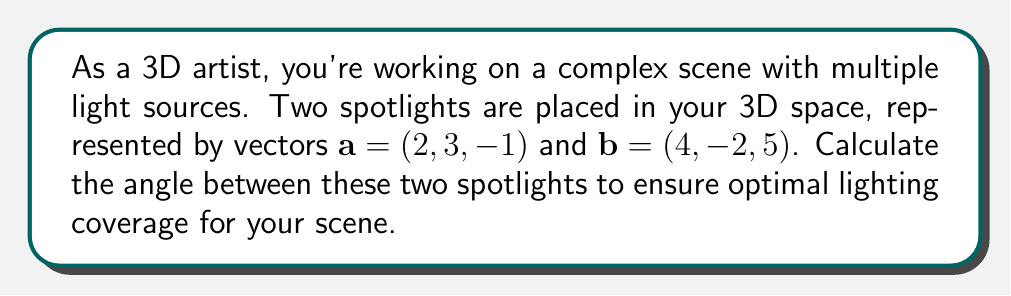Teach me how to tackle this problem. To calculate the angle between two vectors in 3D space, we can use the dot product formula:

$$\cos \theta = \frac{\mathbf{a} \cdot \mathbf{b}}{|\mathbf{a}||\mathbf{b}|}$$

Where $\theta$ is the angle between the vectors, $\mathbf{a} \cdot \mathbf{b}$ is the dot product of the vectors, and $|\mathbf{a}|$ and $|\mathbf{b}|$ are the magnitudes of vectors $\mathbf{a}$ and $\mathbf{b}$ respectively.

Step 1: Calculate the dot product $\mathbf{a} \cdot \mathbf{b}$
$$\mathbf{a} \cdot \mathbf{b} = (2)(4) + (3)(-2) + (-1)(5) = 8 - 6 - 5 = -3$$

Step 2: Calculate the magnitudes of vectors $\mathbf{a}$ and $\mathbf{b}$
$$|\mathbf{a}| = \sqrt{2^2 + 3^2 + (-1)^2} = \sqrt{4 + 9 + 1} = \sqrt{14}$$
$$|\mathbf{b}| = \sqrt{4^2 + (-2)^2 + 5^2} = \sqrt{16 + 4 + 25} = \sqrt{45}$$

Step 3: Apply the dot product formula
$$\cos \theta = \frac{-3}{\sqrt{14}\sqrt{45}}$$

Step 4: Calculate $\theta$ using the inverse cosine (arccos) function
$$\theta = \arccos\left(\frac{-3}{\sqrt{14}\sqrt{45}}\right)$$

Step 5: Convert to degrees (optional, depending on preferred output)
$$\theta_{degrees} = \theta \cdot \frac{180}{\pi}$$
Answer: The angle between the two spotlights is $\theta = \arccos\left(\frac{-3}{\sqrt{14}\sqrt{45}}\right)$ radians, or approximately 98.21 degrees. 